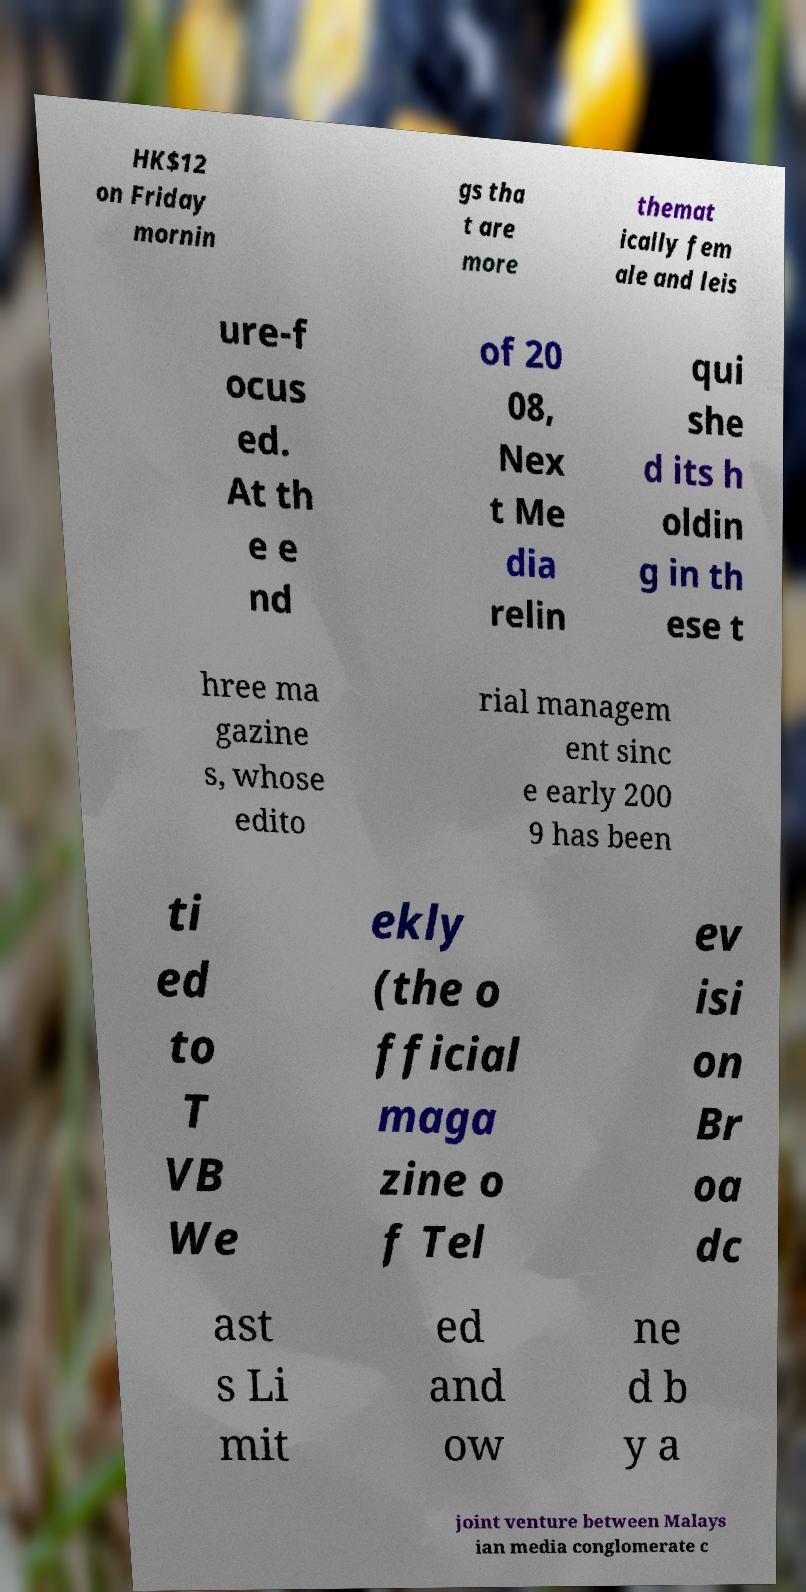Could you assist in decoding the text presented in this image and type it out clearly? HK$12 on Friday mornin gs tha t are more themat ically fem ale and leis ure-f ocus ed. At th e e nd of 20 08, Nex t Me dia relin qui she d its h oldin g in th ese t hree ma gazine s, whose edito rial managem ent sinc e early 200 9 has been ti ed to T VB We ekly (the o fficial maga zine o f Tel ev isi on Br oa dc ast s Li mit ed and ow ne d b y a joint venture between Malays ian media conglomerate c 